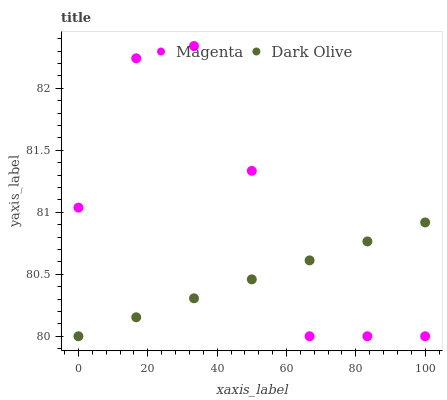Does Dark Olive have the minimum area under the curve?
Answer yes or no. Yes. Does Magenta have the maximum area under the curve?
Answer yes or no. Yes. Does Dark Olive have the maximum area under the curve?
Answer yes or no. No. Is Dark Olive the smoothest?
Answer yes or no. Yes. Is Magenta the roughest?
Answer yes or no. Yes. Is Dark Olive the roughest?
Answer yes or no. No. Does Magenta have the lowest value?
Answer yes or no. Yes. Does Magenta have the highest value?
Answer yes or no. Yes. Does Dark Olive have the highest value?
Answer yes or no. No. Does Dark Olive intersect Magenta?
Answer yes or no. Yes. Is Dark Olive less than Magenta?
Answer yes or no. No. Is Dark Olive greater than Magenta?
Answer yes or no. No. 